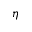Convert formula to latex. <formula><loc_0><loc_0><loc_500><loc_500>\eta</formula> 